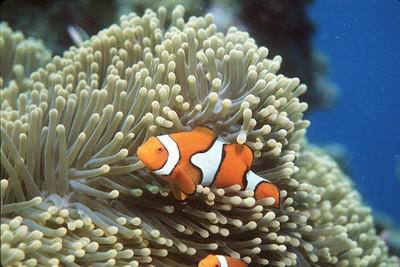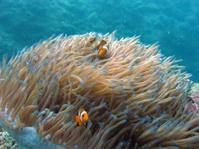The first image is the image on the left, the second image is the image on the right. For the images displayed, is the sentence "At least 2 clown fish are swimming near a large sea urchin." factually correct? Answer yes or no. Yes. The first image is the image on the left, the second image is the image on the right. Assess this claim about the two images: "One image shows a single prominent clownfish with head and body facing left, in front of neutral-colored anemone tendrils.". Correct or not? Answer yes or no. Yes. 